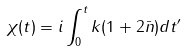Convert formula to latex. <formula><loc_0><loc_0><loc_500><loc_500>\chi ( t ) = i \int _ { 0 } ^ { t } k ( 1 + 2 \bar { n } ) d t ^ { \prime }</formula> 